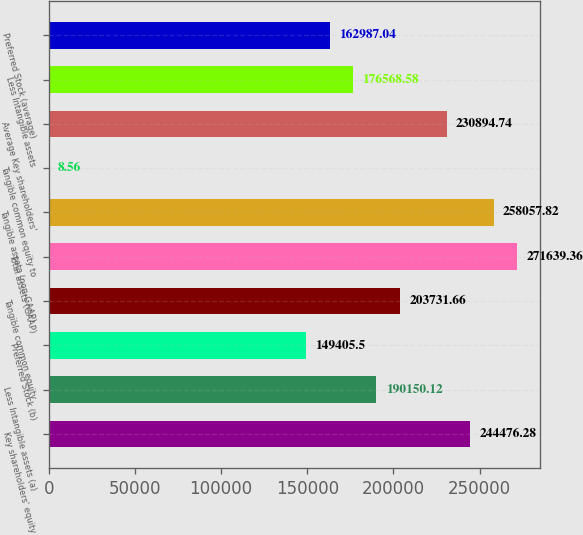Convert chart. <chart><loc_0><loc_0><loc_500><loc_500><bar_chart><fcel>Key shareholders' equity<fcel>Less Intangible assets (a)<fcel>Preferred Stock (b)<fcel>Tangible common equity<fcel>Total assets (GAAP)<fcel>Tangible assets (non-GAAP)<fcel>Tangible common equity to<fcel>Average Key shareholders'<fcel>Less Intangible assets<fcel>Preferred Stock (average)<nl><fcel>244476<fcel>190150<fcel>149406<fcel>203732<fcel>271639<fcel>258058<fcel>8.56<fcel>230895<fcel>176569<fcel>162987<nl></chart> 